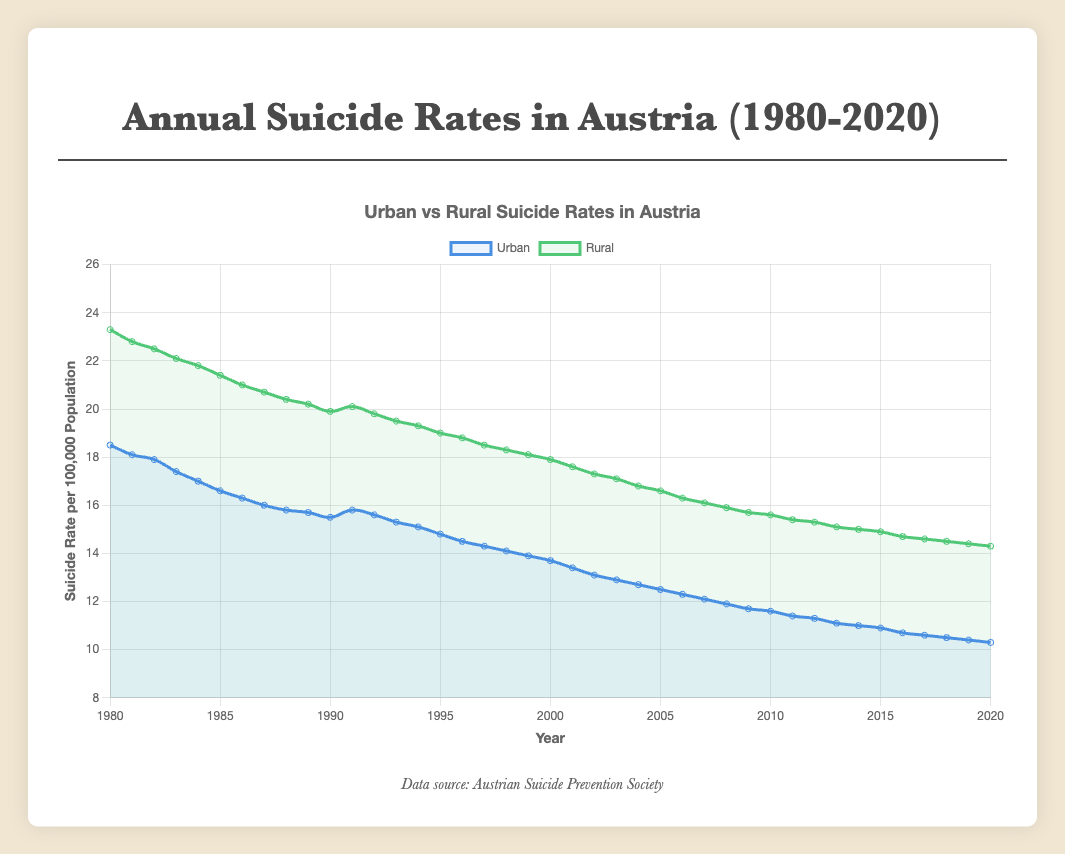What is the overall trend in suicide rates for both urban and rural populations from 1980 to 2020? The overall trend in suicide rates for both urban and rural populations shows a steady decline from 1980 to 2020. Urban rates dropped from 18.5 in 1980 to 10.3 in 2020, and rural rates decreased from 23.3 in 1980 to 14.3 in 2020.
Answer: Steady decline Which year had the largest difference in suicide rates between urban and rural populations? By visually inspecting the distance between the urban and rural curves across the years, the largest difference appears around 1980. Specifically, in 1980, the difference is 23.3 (rural) - 18.5 (urban) = 4.8.
Answer: 1980 How much did the urban suicide rate decrease from 1980 to 2020? The urban suicide rate in 1980 was 18.5 and in 2020 it was 10.3. The decrease is calculated as 18.5 - 10.3 = 8.2.
Answer: 8.2 In which year did the urban suicide rate become lower than 15 for the first time? By looking at the downward trend of the urban suicide rate curve, the urban rate first dips below 15 in the year 1994, when it registers at 14.8.
Answer: 1994 Compare the suicide rates in rural and urban populations in the year 2010. Which is higher and by how much? In 2010, the urban suicide rate was 11.6 and the rural suicide rate was 15.6. The rural rate is higher by 15.6 - 11.6 = 4.
Answer: Rural by 4 Identify a period during which the decline in rural suicide rates was most rapid. Through visual inspection, the most rapid decline in rural suicide rates seems to occur between 1980 and 1990, where rates drop from 23.3 to 19.9. This 3.4-point drop over 10 years represents a relatively steep decline compared to other periods.
Answer: 1980-1990 What was the average suicide rate for urban populations in the years 2000 to 2010? The average rate is calculated by summing the urban suicide rates from 2000 to 2010 and dividing by the number of years. (13.7+13.4+13.1+12.9+12.7+12.5+12.3+12.1+11.9+11.7+11.6) / 11 = 12.67 (rounded to two decimal places).
Answer: 12.67 Did the urban or rural population see a greater relative decline in suicide rates from 1980 to 2020? For the urban population, the rate declined from 18.5 to 10.3, a relative decline of (18.5 - 10.3) / 18.5 ≈ 0.44 or 44%. For the rural population, the rate declined from 23.3 to 14.3, a relative decline of (23.3 - 14.3) / 23.3 ≈ 0.39 or 39%. Thus, the urban population saw a greater relative decline.
Answer: Urban What is the visual relationship between the color-coded lines on the graph? The urban suicide rate line is represented by a blue curve and the rural suicide rate line is depicted by a green curve. Both lines show a decreasing trend but the green line (rural) is consistently higher than the blue line (urban) across the years.
Answer: Blue for urban, green for rural In which decade did the rural suicide rate see the least reduction? Examining the decades, the reduction seems least significant between 2010 and 2020, where the drop is from 15.6 to 14.3. The reduction is 1.3, which is smaller compared to previous decades.
Answer: 2010-2020 